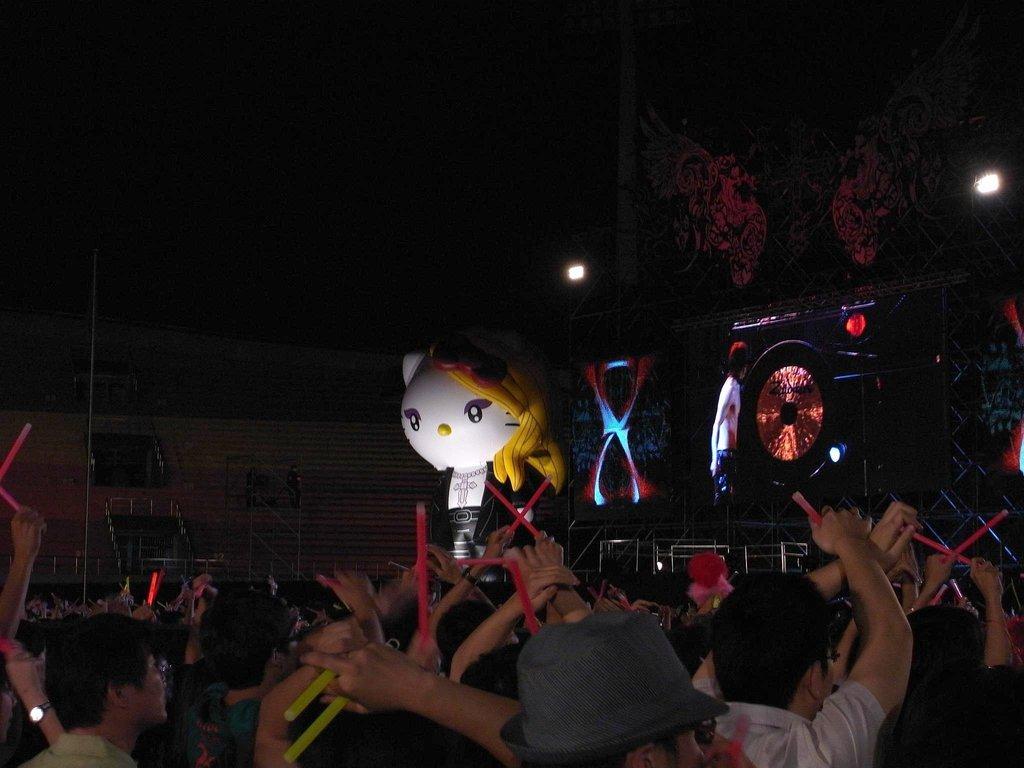Can you describe this image briefly? In this picture I can see a stadium, there are group of people holding some objects, there is a mascot, there is a screen, there are lights, and there is dark background. 